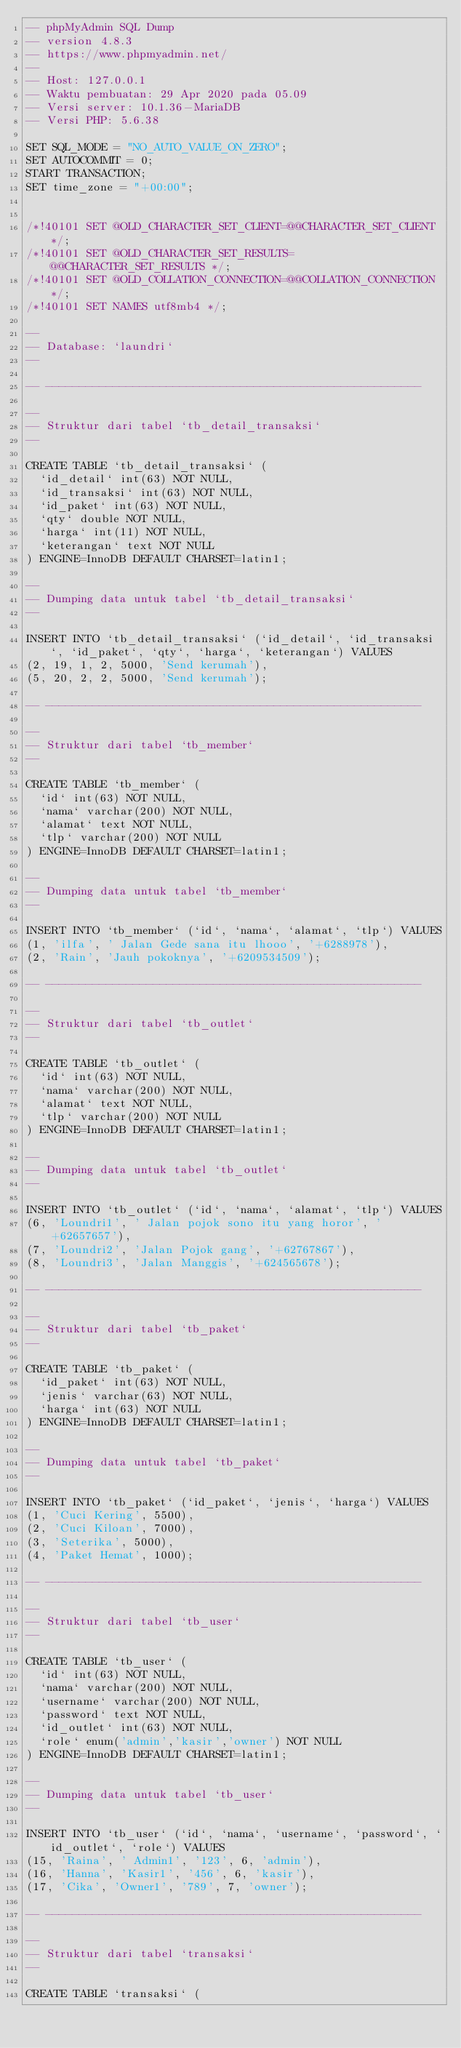<code> <loc_0><loc_0><loc_500><loc_500><_SQL_>-- phpMyAdmin SQL Dump
-- version 4.8.3
-- https://www.phpmyadmin.net/
--
-- Host: 127.0.0.1
-- Waktu pembuatan: 29 Apr 2020 pada 05.09
-- Versi server: 10.1.36-MariaDB
-- Versi PHP: 5.6.38

SET SQL_MODE = "NO_AUTO_VALUE_ON_ZERO";
SET AUTOCOMMIT = 0;
START TRANSACTION;
SET time_zone = "+00:00";


/*!40101 SET @OLD_CHARACTER_SET_CLIENT=@@CHARACTER_SET_CLIENT */;
/*!40101 SET @OLD_CHARACTER_SET_RESULTS=@@CHARACTER_SET_RESULTS */;
/*!40101 SET @OLD_COLLATION_CONNECTION=@@COLLATION_CONNECTION */;
/*!40101 SET NAMES utf8mb4 */;

--
-- Database: `laundri`
--

-- --------------------------------------------------------

--
-- Struktur dari tabel `tb_detail_transaksi`
--

CREATE TABLE `tb_detail_transaksi` (
  `id_detail` int(63) NOT NULL,
  `id_transaksi` int(63) NOT NULL,
  `id_paket` int(63) NOT NULL,
  `qty` double NOT NULL,
  `harga` int(11) NOT NULL,
  `keterangan` text NOT NULL
) ENGINE=InnoDB DEFAULT CHARSET=latin1;

--
-- Dumping data untuk tabel `tb_detail_transaksi`
--

INSERT INTO `tb_detail_transaksi` (`id_detail`, `id_transaksi`, `id_paket`, `qty`, `harga`, `keterangan`) VALUES
(2, 19, 1, 2, 5000, 'Send kerumah'),
(5, 20, 2, 2, 5000, 'Send kerumah');

-- --------------------------------------------------------

--
-- Struktur dari tabel `tb_member`
--

CREATE TABLE `tb_member` (
  `id` int(63) NOT NULL,
  `nama` varchar(200) NOT NULL,
  `alamat` text NOT NULL,
  `tlp` varchar(200) NOT NULL
) ENGINE=InnoDB DEFAULT CHARSET=latin1;

--
-- Dumping data untuk tabel `tb_member`
--

INSERT INTO `tb_member` (`id`, `nama`, `alamat`, `tlp`) VALUES
(1, 'ilfa', ' Jalan Gede sana itu lhooo', '+6288978'),
(2, 'Rain', 'Jauh pokoknya', '+6209534509');

-- --------------------------------------------------------

--
-- Struktur dari tabel `tb_outlet`
--

CREATE TABLE `tb_outlet` (
  `id` int(63) NOT NULL,
  `nama` varchar(200) NOT NULL,
  `alamat` text NOT NULL,
  `tlp` varchar(200) NOT NULL
) ENGINE=InnoDB DEFAULT CHARSET=latin1;

--
-- Dumping data untuk tabel `tb_outlet`
--

INSERT INTO `tb_outlet` (`id`, `nama`, `alamat`, `tlp`) VALUES
(6, 'Loundri1', ' Jalan pojok sono itu yang horor', ' +62657657'),
(7, 'Loundri2', 'Jalan Pojok gang', '+62767867'),
(8, 'Loundri3', 'Jalan Manggis', '+624565678');

-- --------------------------------------------------------

--
-- Struktur dari tabel `tb_paket`
--

CREATE TABLE `tb_paket` (
  `id_paket` int(63) NOT NULL,
  `jenis` varchar(63) NOT NULL,
  `harga` int(63) NOT NULL
) ENGINE=InnoDB DEFAULT CHARSET=latin1;

--
-- Dumping data untuk tabel `tb_paket`
--

INSERT INTO `tb_paket` (`id_paket`, `jenis`, `harga`) VALUES
(1, 'Cuci Kering', 5500),
(2, 'Cuci Kiloan', 7000),
(3, 'Seterika', 5000),
(4, 'Paket Hemat', 1000);

-- --------------------------------------------------------

--
-- Struktur dari tabel `tb_user`
--

CREATE TABLE `tb_user` (
  `id` int(63) NOT NULL,
  `nama` varchar(200) NOT NULL,
  `username` varchar(200) NOT NULL,
  `password` text NOT NULL,
  `id_outlet` int(63) NOT NULL,
  `role` enum('admin','kasir','owner') NOT NULL
) ENGINE=InnoDB DEFAULT CHARSET=latin1;

--
-- Dumping data untuk tabel `tb_user`
--

INSERT INTO `tb_user` (`id`, `nama`, `username`, `password`, `id_outlet`, `role`) VALUES
(15, 'Raina', ' Admin1', '123', 6, 'admin'),
(16, 'Hanna', 'Kasir1', '456', 6, 'kasir'),
(17, 'Cika', 'Owner1', '789', 7, 'owner');

-- --------------------------------------------------------

--
-- Struktur dari tabel `transaksi`
--

CREATE TABLE `transaksi` (</code> 